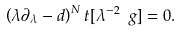Convert formula to latex. <formula><loc_0><loc_0><loc_500><loc_500>\left ( \lambda \partial _ { \lambda } - d \right ) ^ { N } t [ \lambda ^ { - 2 } \ g ] = 0 .</formula> 